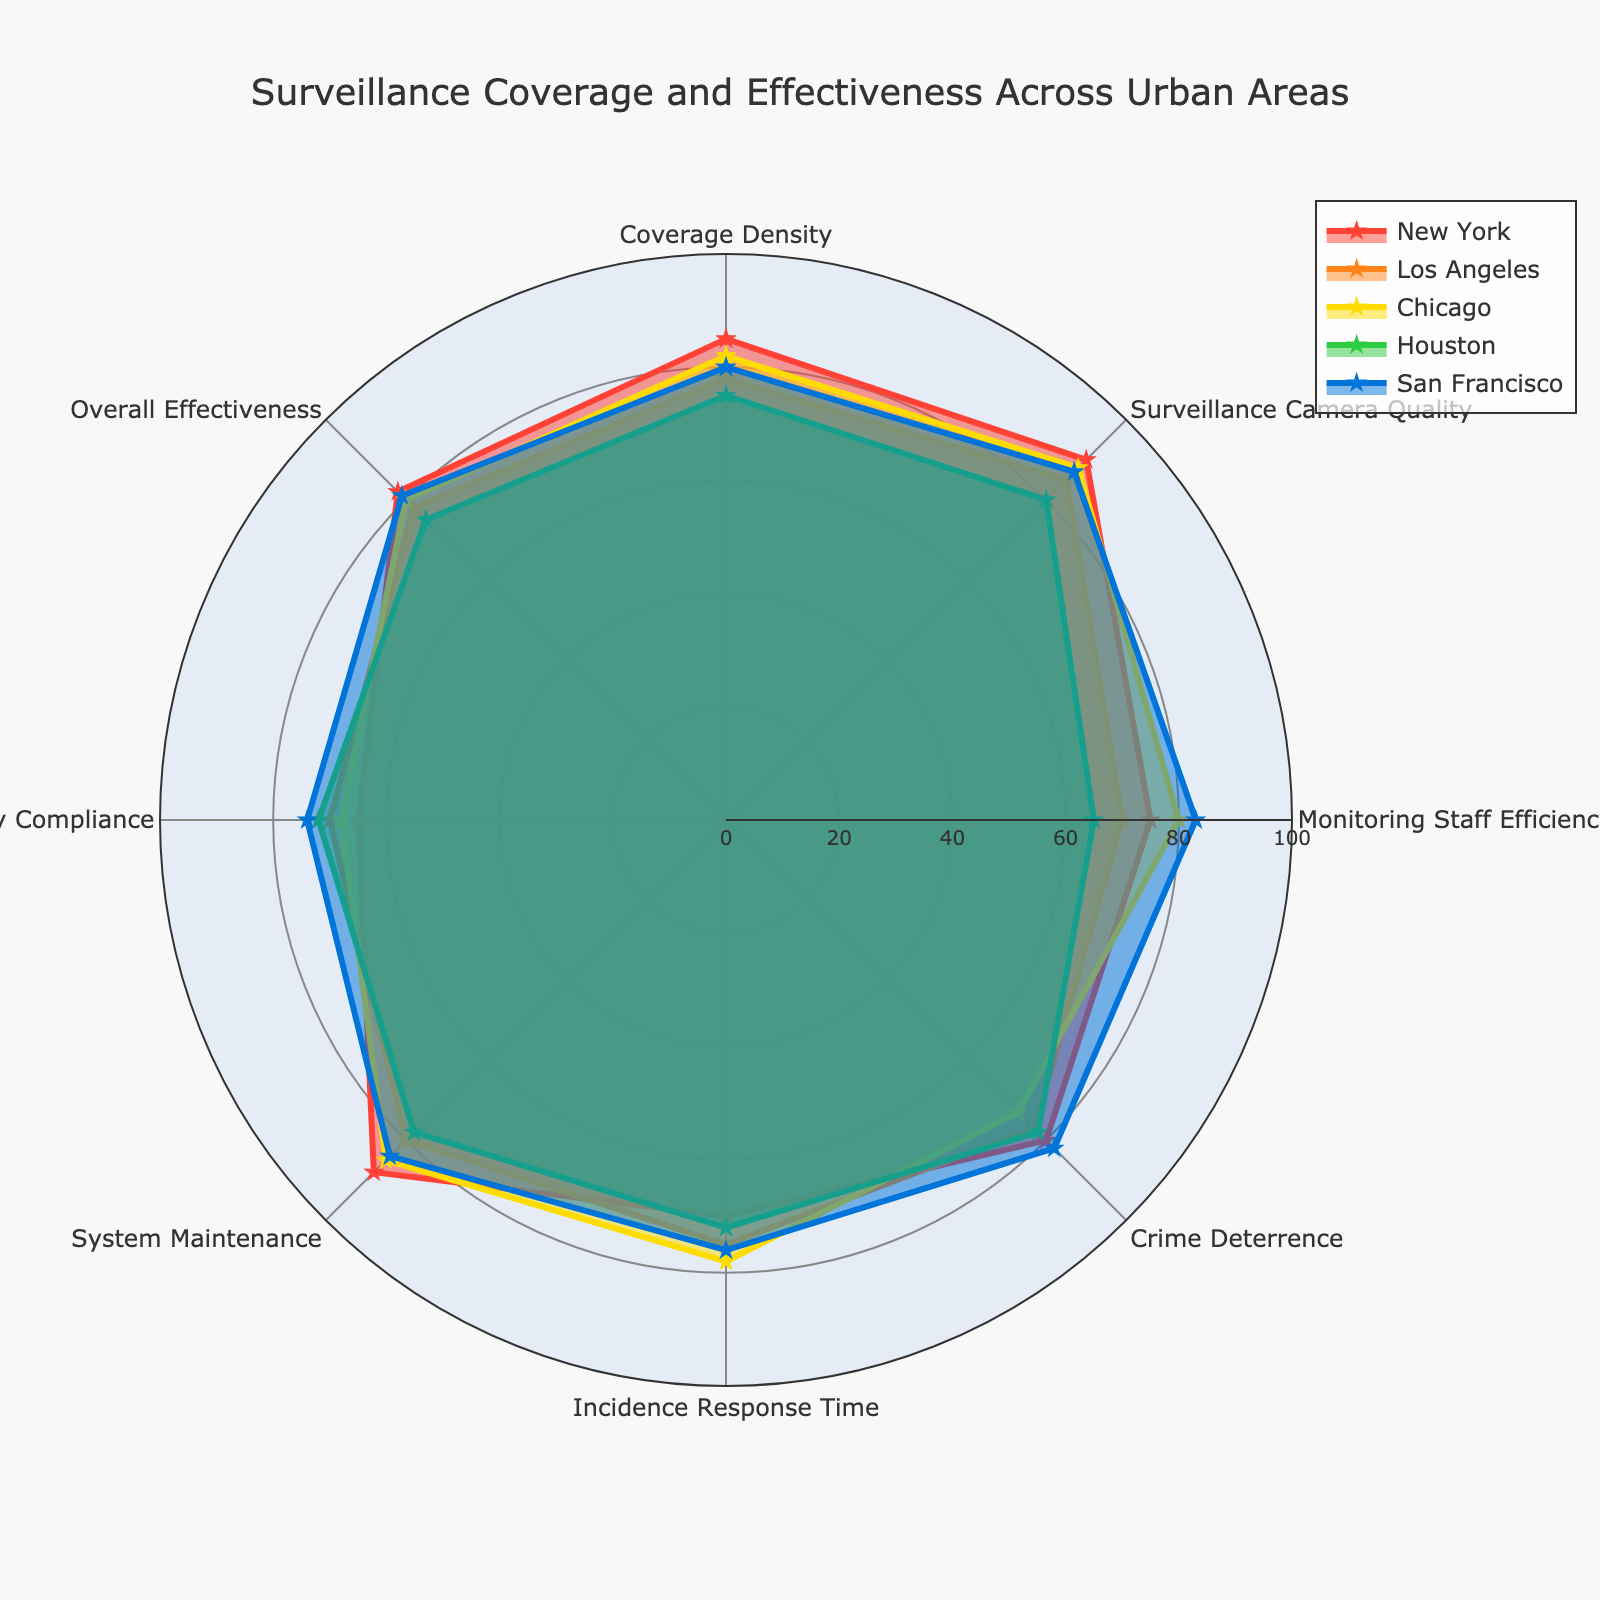What is the title of the radar chart? The title of the chart is displayed at the top and states the purpose of the figure.
Answer: Surveillance Coverage and Effectiveness Across Urban Areas Which city has the lowest rating in Monitoring Staff Efficiency? To find the answer, compare the Monitoring Staff Efficiency values for all cities. Houston has the lowest value (65).
Answer: Houston What is the average value of Crime Deterrence across all cities? Add the Crime Deterrence values for all cities (80 (New York) + 77 (Los Angeles) + 73 (Chicago) + 78 (Houston) + 82 (San Francisco)) and divide by the number of cities (5). The calculation is (80+77+73+78+82)/5 = 78.
Answer: 78 Which category has the highest value for San Francisco? To find the highest value for San Francisco, compare all category values. The highest value is in Monitoring Staff Efficiency (83).
Answer: Monitoring Staff Efficiency How does New York's Privacy Compliance compare to Los Angeles's Privacy Compliance? Compare the values for Privacy Compliance. New York has a value of 65, while Los Angeles has a value of 70. New York’s value is lower than Los Angeles's.
Answer: New York's Privacy Compliance is lower than Los Angeles's Which category has the least variance across all cities? For each category, calculate the range (difference between max and min values). System Maintenance has the smallest range (88 (Max) - 78 (Min) = 10).
Answer: System Maintenance What is the difference between the highest and lowest values for Chicago? Determine the highest (Surveillance Camera Quality, 88) and lowest (Privacy Compliance, 68) values for Chicago and find the difference (88-68).
Answer: 20 Which city has the most balanced performance across all categories? The most balanced performance can be interpreted as the city with the least variance between its highest and lowest values. San Francisco has the values most closely clustered together (between 74 and 87).
Answer: San Francisco Which city has the highest average score across all categories? Sum all category values for each city and divide by the number of categories (8). New York has the highest total (85+90+75+80+70+88+65+82 = 635) and the highest average (635/8 = 79.375).
Answer: New York How does San Francisco's Incidence Response Time compare to Chicago's? Compare the values for Incidence Response Time. San Francisco has a value of 76, while Chicago has a value of 78. San Francisco’s value is lower.
Answer: San Francisco's Incidence Response Time is lower than Chicago's 